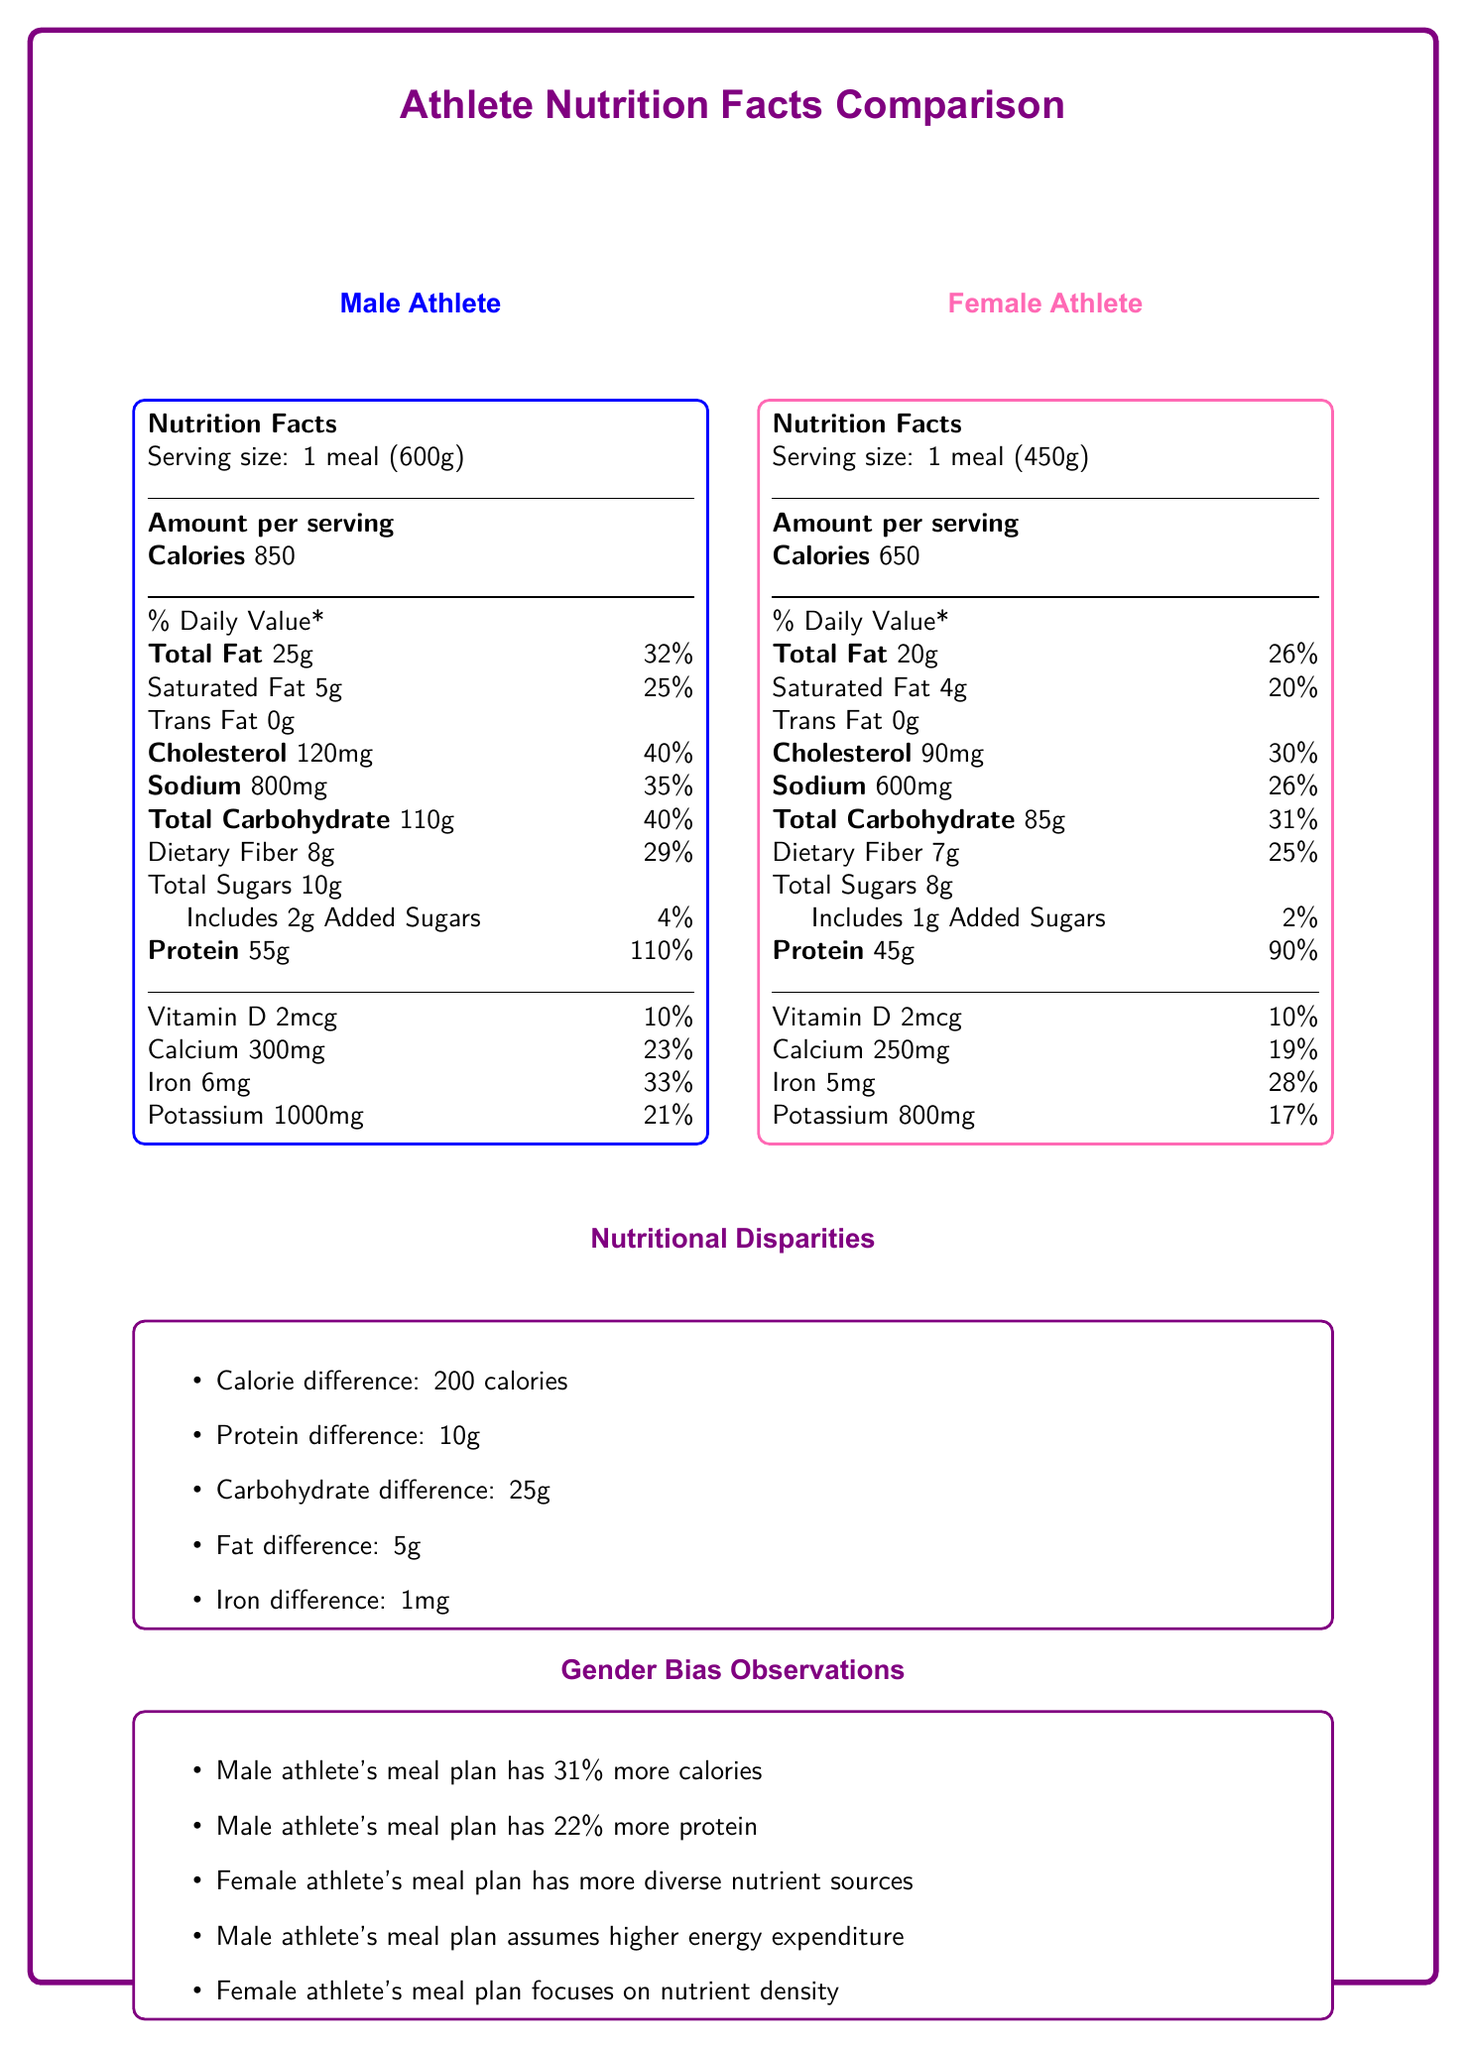what is the serving size for the male athlete's meal plan? The serving size for the male athlete's meal plan is listed as 1 meal (600g) in the "Male Athlete" section.
Answer: 1 meal (600g) compare the calorie content of the male and female athlete's meal plans. The male athlete's meal has 850 calories, while the female athlete's meal has 650 calories, as specified in their respective sections.
Answer: Male: 850 calories, Female: 650 calories how much protein does the female athlete's meal plan provide? The female athlete's meal plan provides 45g of protein, according to the "Female Athlete" section.
Answer: 45g what is the cholesterol content in the male athlete's meal? The male athlete's meal contains 120mg of cholesterol, which is indicated in the "Male Athlete" section.
Answer: 120mg what are the main components of the male athlete's meal? The main components of the male athlete's meal are listed in the "meal_components" part of the "male_athlete_meal_plan" data.
Answer: Grilled chicken breast (200g), Brown rice (150g), Steamed broccoli (100g), Sweet potato (100g), Olive oil (1 tbsp), Protein shake (1 scoop) which athlete's meal plan has more saturated fat, and by how much? The male athlete's meal plan has 5g of saturated fat, while the female athlete's meal plan has 4g, making it 1g higher for the male athlete.
Answer: Male by 1g how much iron is in the female athlete's meal plan compared to the male athlete's meal plan? The female athlete's meal plan contains 5mg of iron, whereas the male athlete's meal plan has 6mg of iron, as listed in their respective sections.
Answer: Female: 5mg, Male: 6mg which meal plan has higher sodium content? The male athlete's meal plan contains 800mg of sodium, while the female athlete's meal plan has 600mg, indicating that the male meal plan has higher sodium content.
Answer: Male what percentage of the daily value of protein does the female athlete's meal provide? The percentage of daily value for protein in the female athlete's meal is 90%, as listed in the "Female Athlete" nutrition facts.
Answer: 90% what is the main idea of the document? The document provides side-by-side Nutrition Facts Labels for both meal plans, points out nutritional differences, discusses gender bias, and suggests factors to consider for equality in athletic nutrition.
Answer: The document compares the nutritional content of meal plans for male and female athletes, highlighting disparities in calories, protein, and other nutrients, and includes gender bias observations and equality considerations. which nutrient is present in equal amounts in both male and female athletes' meal plans? A. Saturated Fat B. Vitamin D C. Calcium D. Potassium Both meal plans contain 2mcg of Vitamin D, as indicated in their respective sections.
Answer: B. Vitamin D what is the difference in carbohydrate content between the male and female athlete's meal plans? A. 10g B. 15g C. 25g D. 30g The male athlete's meal plan has 110g of carbohydrates, while the female athlete's meal plan has 85g, making the difference 25g.
Answer: C. 25g does the female athlete's meal plan include more dietary fiber than the male athlete's meal plan? The female athlete's meal plan includes 7g of dietary fiber, whereas the male athlete's meal plan contains 8g.
Answer: No is the female athlete's meal plan more focused on nutrient density compared to the male athlete's meal plan? The gender bias observations state that the female athlete's meal plan focuses on nutrient density, as opposed to the male athlete's plan, which assumes higher energy expenditure.
Answer: Yes what are the equality considerations mentioned in the document? The document lists these considerations to promote equality in nutritional approaches for athletes.
Answer: Individualized nutrition plans, equal access to high-quality protein, addressing female-specific nutritional needs, promoting body positivity and performance, education on proper fueling why does the male athlete's meal plan have higher caloric content than the female athlete's meal plan? The document does not provide a specific reason for the higher caloric content in the male athlete's meal plan; it may be due to various factors such as assumed higher energy expenditure, which is mentioned in the gender bias observations.
Answer: Not enough information 